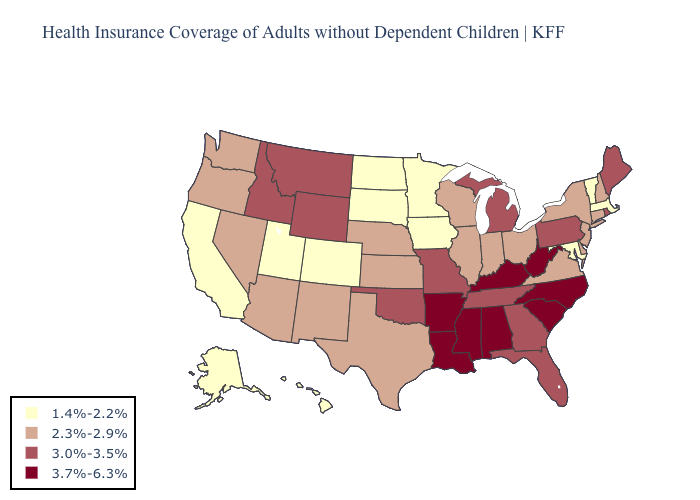What is the highest value in the Northeast ?
Concise answer only. 3.0%-3.5%. What is the value of Alaska?
Answer briefly. 1.4%-2.2%. Does Mississippi have the same value as Kentucky?
Concise answer only. Yes. Which states have the lowest value in the South?
Quick response, please. Maryland. Does New Hampshire have the highest value in the Northeast?
Quick response, please. No. Which states have the lowest value in the Northeast?
Give a very brief answer. Massachusetts, Vermont. Does Louisiana have the highest value in the USA?
Quick response, please. Yes. What is the value of California?
Short answer required. 1.4%-2.2%. Among the states that border Georgia , which have the highest value?
Give a very brief answer. Alabama, North Carolina, South Carolina. What is the value of Oklahoma?
Write a very short answer. 3.0%-3.5%. Name the states that have a value in the range 2.3%-2.9%?
Give a very brief answer. Arizona, Connecticut, Delaware, Illinois, Indiana, Kansas, Nebraska, Nevada, New Hampshire, New Jersey, New Mexico, New York, Ohio, Oregon, Texas, Virginia, Washington, Wisconsin. Among the states that border Tennessee , does Kentucky have the highest value?
Answer briefly. Yes. How many symbols are there in the legend?
Answer briefly. 4. Which states have the lowest value in the USA?
Quick response, please. Alaska, California, Colorado, Hawaii, Iowa, Maryland, Massachusetts, Minnesota, North Dakota, South Dakota, Utah, Vermont. What is the value of Washington?
Keep it brief. 2.3%-2.9%. 